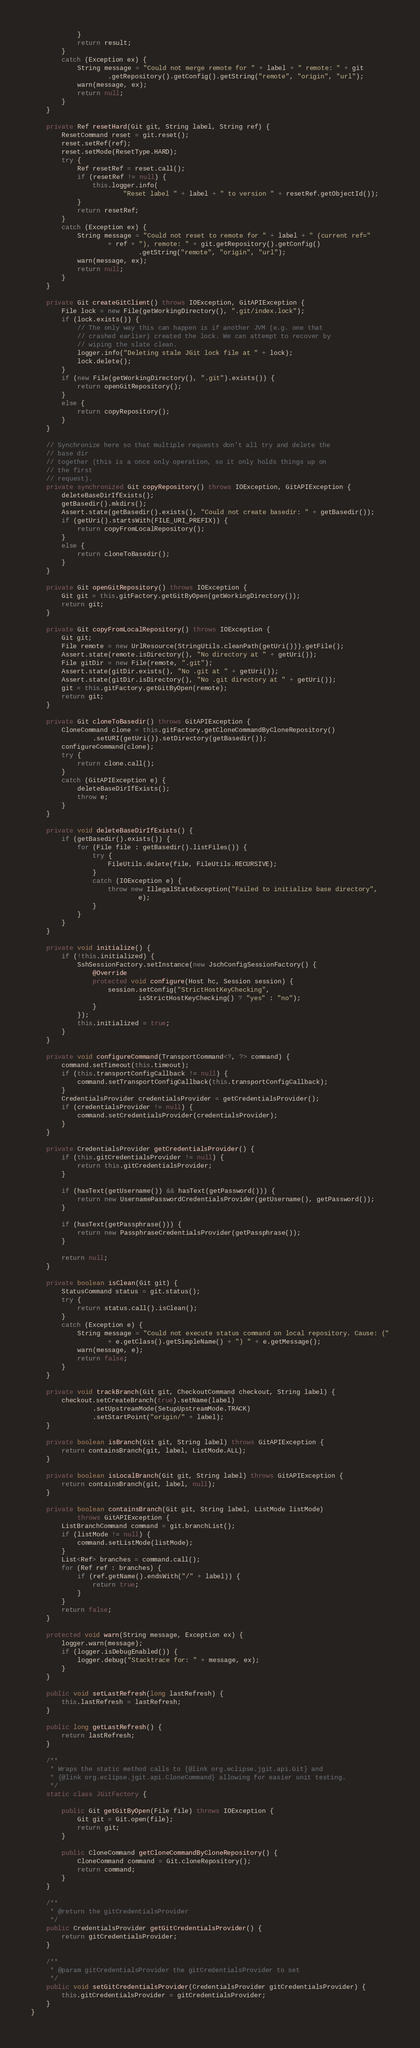<code> <loc_0><loc_0><loc_500><loc_500><_Java_>			}
			return result;
		}
		catch (Exception ex) {
			String message = "Could not merge remote for " + label + " remote: " + git
					.getRepository().getConfig().getString("remote", "origin", "url");
			warn(message, ex);
			return null;
		}
	}

	private Ref resetHard(Git git, String label, String ref) {
		ResetCommand reset = git.reset();
		reset.setRef(ref);
		reset.setMode(ResetType.HARD);
		try {
			Ref resetRef = reset.call();
			if (resetRef != null) {
				this.logger.info(
						"Reset label " + label + " to version " + resetRef.getObjectId());
			}
			return resetRef;
		}
		catch (Exception ex) {
			String message = "Could not reset to remote for " + label + " (current ref="
					+ ref + "), remote: " + git.getRepository().getConfig()
							.getString("remote", "origin", "url");
			warn(message, ex);
			return null;
		}
	}

	private Git createGitClient() throws IOException, GitAPIException {
		File lock = new File(getWorkingDirectory(), ".git/index.lock");
		if (lock.exists()) {
			// The only way this can happen is if another JVM (e.g. one that
			// crashed earlier) created the lock. We can attempt to recover by
			// wiping the slate clean.
			logger.info("Deleting stale JGit lock file at " + lock);
			lock.delete();
		}
		if (new File(getWorkingDirectory(), ".git").exists()) {
			return openGitRepository();
		}
		else {
			return copyRepository();
		}
	}

	// Synchronize here so that multiple requests don't all try and delete the
	// base dir
	// together (this is a once only operation, so it only holds things up on
	// the first
	// request).
	private synchronized Git copyRepository() throws IOException, GitAPIException {
		deleteBaseDirIfExists();
		getBasedir().mkdirs();
		Assert.state(getBasedir().exists(), "Could not create basedir: " + getBasedir());
		if (getUri().startsWith(FILE_URI_PREFIX)) {
			return copyFromLocalRepository();
		}
		else {
			return cloneToBasedir();
		}
	}

	private Git openGitRepository() throws IOException {
		Git git = this.gitFactory.getGitByOpen(getWorkingDirectory());
		return git;
	}

	private Git copyFromLocalRepository() throws IOException {
		Git git;
		File remote = new UrlResource(StringUtils.cleanPath(getUri())).getFile();
		Assert.state(remote.isDirectory(), "No directory at " + getUri());
		File gitDir = new File(remote, ".git");
		Assert.state(gitDir.exists(), "No .git at " + getUri());
		Assert.state(gitDir.isDirectory(), "No .git directory at " + getUri());
		git = this.gitFactory.getGitByOpen(remote);
		return git;
	}

	private Git cloneToBasedir() throws GitAPIException {
		CloneCommand clone = this.gitFactory.getCloneCommandByCloneRepository()
				.setURI(getUri()).setDirectory(getBasedir());
		configureCommand(clone);
		try {
			return clone.call();
		}
		catch (GitAPIException e) {
			deleteBaseDirIfExists();
			throw e;
		}
	}

	private void deleteBaseDirIfExists() {
		if (getBasedir().exists()) {
			for (File file : getBasedir().listFiles()) {
				try {
					FileUtils.delete(file, FileUtils.RECURSIVE);
				}
				catch (IOException e) {
					throw new IllegalStateException("Failed to initialize base directory",
							e);
				}
			}
		}
	}

	private void initialize() {
		if (!this.initialized) {
			SshSessionFactory.setInstance(new JschConfigSessionFactory() {
				@Override
				protected void configure(Host hc, Session session) {
					session.setConfig("StrictHostKeyChecking",
							isStrictHostKeyChecking() ? "yes" : "no");
				}
			});
			this.initialized = true;
		}
	}

	private void configureCommand(TransportCommand<?, ?> command) {
		command.setTimeout(this.timeout);
		if (this.transportConfigCallback != null) {
			command.setTransportConfigCallback(this.transportConfigCallback);
		}
		CredentialsProvider credentialsProvider = getCredentialsProvider();
		if (credentialsProvider != null) {
			command.setCredentialsProvider(credentialsProvider);
		}
	}

	private CredentialsProvider getCredentialsProvider() {
		if (this.gitCredentialsProvider != null) {
			return this.gitCredentialsProvider;
		}

		if (hasText(getUsername()) && hasText(getPassword())) {
			return new UsernamePasswordCredentialsProvider(getUsername(), getPassword());
		}

		if (hasText(getPassphrase())) {
			return new PassphraseCredentialsProvider(getPassphrase());
		}

		return null;
	}

	private boolean isClean(Git git) {
		StatusCommand status = git.status();
		try {
			return status.call().isClean();
		}
		catch (Exception e) {
			String message = "Could not execute status command on local repository. Cause: ("
					+ e.getClass().getSimpleName() + ") " + e.getMessage();
			warn(message, e);
			return false;
		}
	}

	private void trackBranch(Git git, CheckoutCommand checkout, String label) {
		checkout.setCreateBranch(true).setName(label)
				.setUpstreamMode(SetupUpstreamMode.TRACK)
				.setStartPoint("origin/" + label);
	}

	private boolean isBranch(Git git, String label) throws GitAPIException {
		return containsBranch(git, label, ListMode.ALL);
	}

	private boolean isLocalBranch(Git git, String label) throws GitAPIException {
		return containsBranch(git, label, null);
	}

	private boolean containsBranch(Git git, String label, ListMode listMode)
			throws GitAPIException {
		ListBranchCommand command = git.branchList();
		if (listMode != null) {
			command.setListMode(listMode);
		}
		List<Ref> branches = command.call();
		for (Ref ref : branches) {
			if (ref.getName().endsWith("/" + label)) {
				return true;
			}
		}
		return false;
	}

	protected void warn(String message, Exception ex) {
		logger.warn(message);
		if (logger.isDebugEnabled()) {
			logger.debug("Stacktrace for: " + message, ex);
		}
	}

	public void setLastRefresh(long lastRefresh) {
		this.lastRefresh = lastRefresh;
	}

	public long getLastRefresh() {
		return lastRefresh;
	}

	/**
	 * Wraps the static method calls to {@link org.eclipse.jgit.api.Git} and
	 * {@link org.eclipse.jgit.api.CloneCommand} allowing for easier unit testing.
	 */
	static class JGitFactory {

		public Git getGitByOpen(File file) throws IOException {
			Git git = Git.open(file);
			return git;
		}

		public CloneCommand getCloneCommandByCloneRepository() {
			CloneCommand command = Git.cloneRepository();
			return command;
		}
	}

	/**
	 * @return the gitCredentialsProvider
	 */
	public CredentialsProvider getGitCredentialsProvider() {
		return gitCredentialsProvider;
	}

	/**
	 * @param gitCredentialsProvider the gitCredentialsProvider to set
	 */
	public void setGitCredentialsProvider(CredentialsProvider gitCredentialsProvider) {
		this.gitCredentialsProvider = gitCredentialsProvider;
	}
}
</code> 